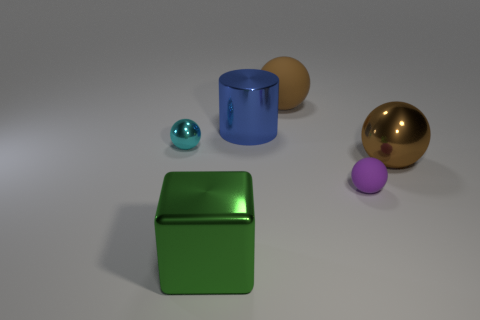Add 3 cyan things. How many objects exist? 9 Subtract all balls. How many objects are left? 2 Subtract all brown metal balls. Subtract all large shiny spheres. How many objects are left? 4 Add 1 blue things. How many blue things are left? 2 Add 6 large blue metal objects. How many large blue metal objects exist? 7 Subtract 0 yellow cylinders. How many objects are left? 6 